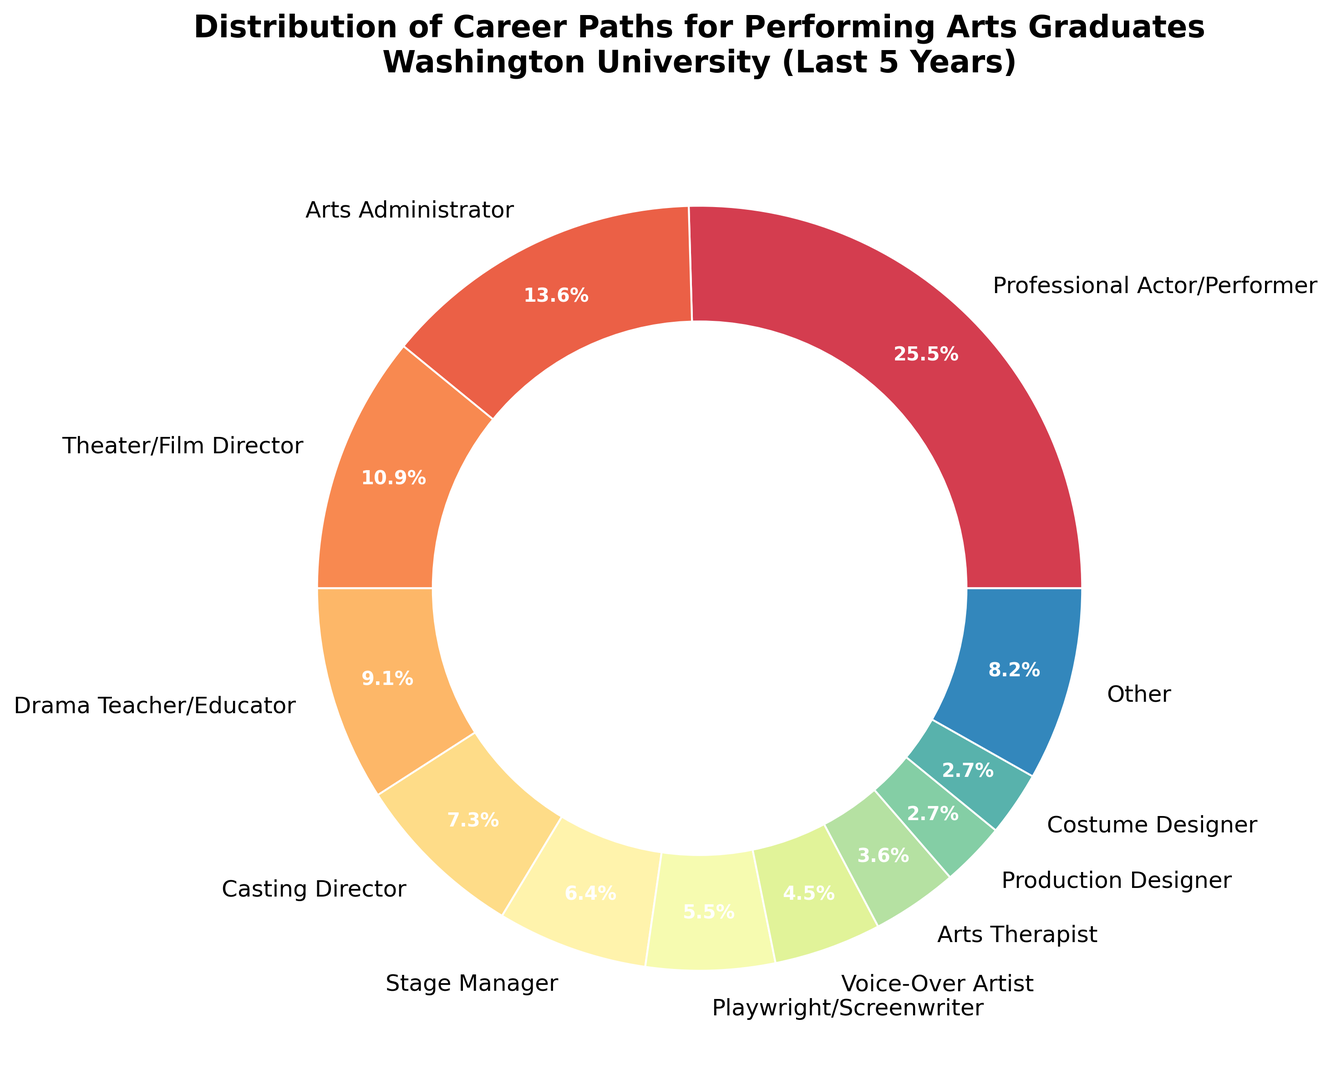What percentage of graduates pursued a career as a Professional Actor/Performer? Look at the slice labeled "Professional Actor/Performer" and check its percentage.
Answer: 28% Which career path has the least percentage in the "Other" category? Identify the paths included in the "Other" category by noting those below the threshold of 3%. The paths are Lighting Designer, Sound Designer, Talent Agent, and Arts Journalist/Critic. The least among these is Arts Journalist/Critic with 1%.
Answer: Arts Journalist/Critic How does the number of graduates in the "Arts Administrator" path compare to the number of graduates in the "Theater/Film Director" path? Reference the slices labeled "Arts Administrator" and "Theater/Film Director" and compare their percentages (15% vs. 12%).
Answer: Arts Administrator > Theater/Film Director What is the combined percentage of graduates working as Playwright/Screenwriter, Voice-Over Artist, and Arts Therapist? Sum the percentages of Playwright/Screenwriter (6%), Voice-Over Artist (5%), and Arts Therapist (4%). Calculation: 6 + 5 + 4 = 15%.
Answer: 15% How does the slice size of Drama Teacher/Educator compare to that of Stage Manager? Compare the percentages of Drama Teacher/Educator (10%) and Stage Manager (7%).
Answer: Drama Teacher/Educator > Stage Manager Describe the color of the wedge representing the "Casting Director" career path. Look at the color assigned to "Casting Director" in the pie chart, which typically follows a gradient: it is somewhere within the spectrum of the chart’s color scheme.
Answer: A middle/neutral color, likely one of the middle hues in the gradient spectrum What category do "Production Designer" and "Costume Designer" belong to in the plot? Since both Production Designer and Costume Designer have a percentage of 3%, they are displayed as individual slices.
Answer: Individual slices What is the visual relationship between the wedge sizes of "Stage Manager" and "Other"? Look at "Stage Manager" and the aggregated "Other" category slices. "Stage Manager" is 7%, while "Other" aggregates smaller slices totaling 11%.
Answer: Other > Stage Manager By how much does the percentage of "Professional Actor/Performer" exceed the percentage of "Arts Administrator"? Subtract the percentage of Arts Administrator from that of Professional Actor/Performer (28% - 15%). Calculation: 28 - 15 = 13%.
Answer: 13% What is the sum of all slices that were aggregated into the "Other" category? Add the percentages of Lighting Designer (2%), Sound Designer (2%), Talent Agent (2%), and Arts Journalist/Critic (1%) which fall below the 3% threshold. Calculation: 2 + 2 + 2 + 1 = 7%.
Answer: 7% 